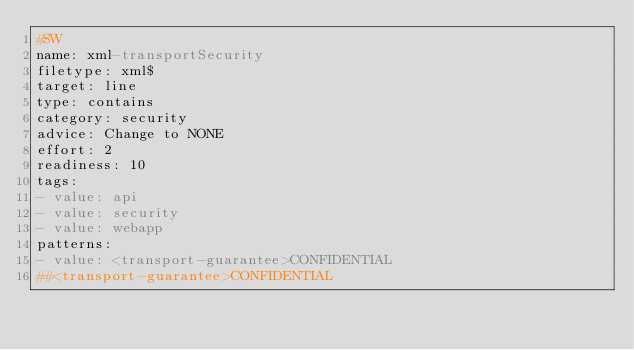<code> <loc_0><loc_0><loc_500><loc_500><_YAML_>#SW
name: xml-transportSecurity
filetype: xml$
target: line
type: contains
category: security
advice: Change to NONE
effort: 2
readiness: 10
tags:
- value: api
- value: security
- value: webapp
patterns:
- value: <transport-guarantee>CONFIDENTIAL
##<transport-guarantee>CONFIDENTIAL
</code> 